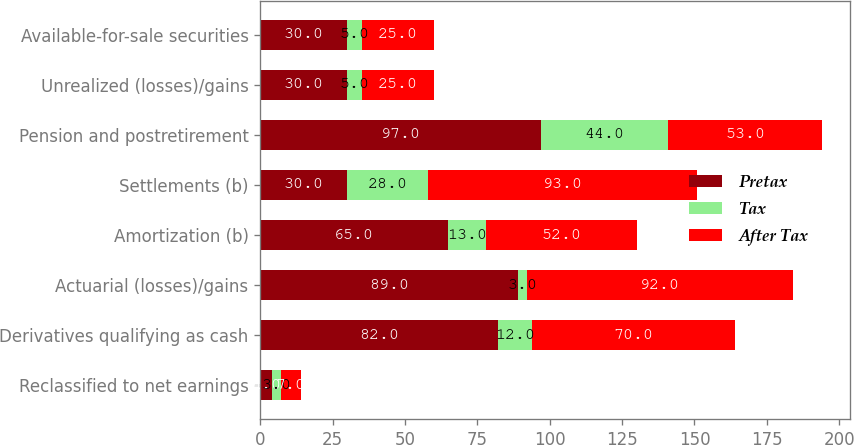Convert chart. <chart><loc_0><loc_0><loc_500><loc_500><stacked_bar_chart><ecel><fcel>Reclassified to net earnings<fcel>Derivatives qualifying as cash<fcel>Actuarial (losses)/gains<fcel>Amortization (b)<fcel>Settlements (b)<fcel>Pension and postretirement<fcel>Unrealized (losses)/gains<fcel>Available-for-sale securities<nl><fcel>Pretax<fcel>4<fcel>82<fcel>89<fcel>65<fcel>30<fcel>97<fcel>30<fcel>30<nl><fcel>Tax<fcel>3<fcel>12<fcel>3<fcel>13<fcel>28<fcel>44<fcel>5<fcel>5<nl><fcel>After Tax<fcel>7<fcel>70<fcel>92<fcel>52<fcel>93<fcel>53<fcel>25<fcel>25<nl></chart> 